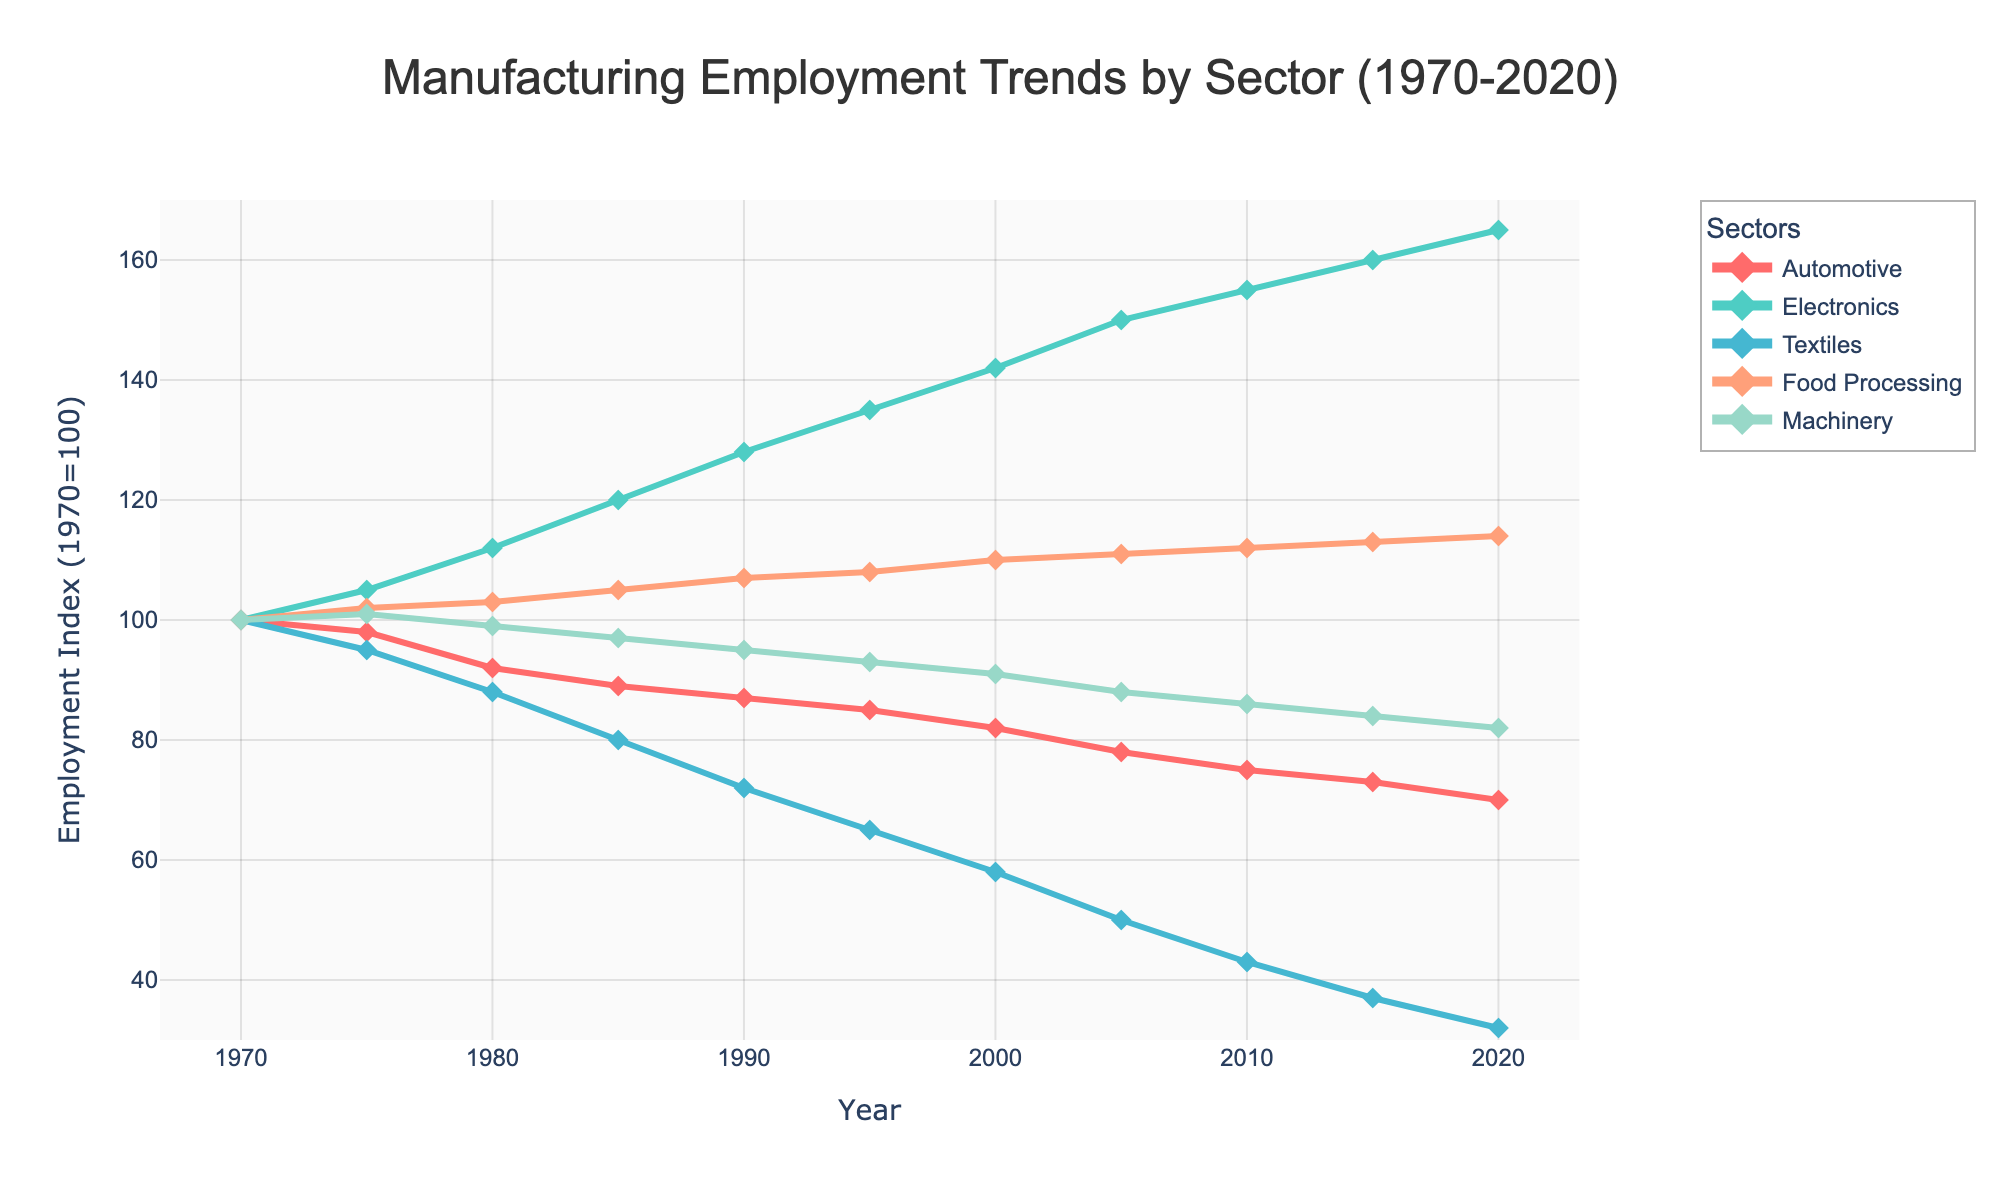What is the employment trend for the Automotive sector from 1970 to 2020? The employment index for the Automotive sector consistently decreased from 100 in 1970 to 70 in 2020, indicating a steady decline over the 50 years.
Answer: Steady decline Between which years did the Electronics sector see the most significant increase in employment? The Electronics sector saw the most significant increase between 1970 (index 100) and 2020 (index 165), with the highest annual jump occurring between 1970 and 1975 (from 100 to 105), and continually increasing each subsequent period.
Answer: 1970 to 1975 Compare the employment trends of the Textiles and Food Processing sectors from 1970 to 2020. Which one declined more? The Textiles sector declined from an index of 100 to 32 (a decrease of 68), whereas the Food Processing sector slightly increased from 100 to 114 (an increase of 14). Thus, the Textiles sector declined significantly more.
Answer: Textiles What is the combined employment index of the Automotive and Machinery sectors in 2020? The employment index for the Automotive sector in 2020 is 70, and for Machinery, it's 82. Summing them up gives 70 + 82 = 152.
Answer: 152 Which sector had the highest employment index in 1990, and what was its value? The Electronics sector had the highest employment index in 1990, with a value of 128.
Answer: Electronics, 128 What is the average employment index for the Food Processing sector from 1970 to 2020? Summing the employment index values for Food Processing from 1970 to 2020 gives (100 + 102 + 103 + 105 + 107 + 108 + 110 + 111 + 112 + 113 + 114) = 1085. Dividing by 11 gives an average of 1085 / 11 ≈ 98.64.
Answer: 98.64 By how much did the Machinery sector's employment index change from 1970 to 2020? The Machinery sector's employment index changed from 100 in 1970 to 82 in 2020, a decrease of 100 - 82 = 18.
Answer: 18 During which decade did the Textiles sector see the sharpest decline in employment? The sharpest decline in the Textiles sector occurred from 1970 to 1980, where the index dropped from 100 to 88, a drop of 12 points within a decade.
Answer: 1970 to 1980 